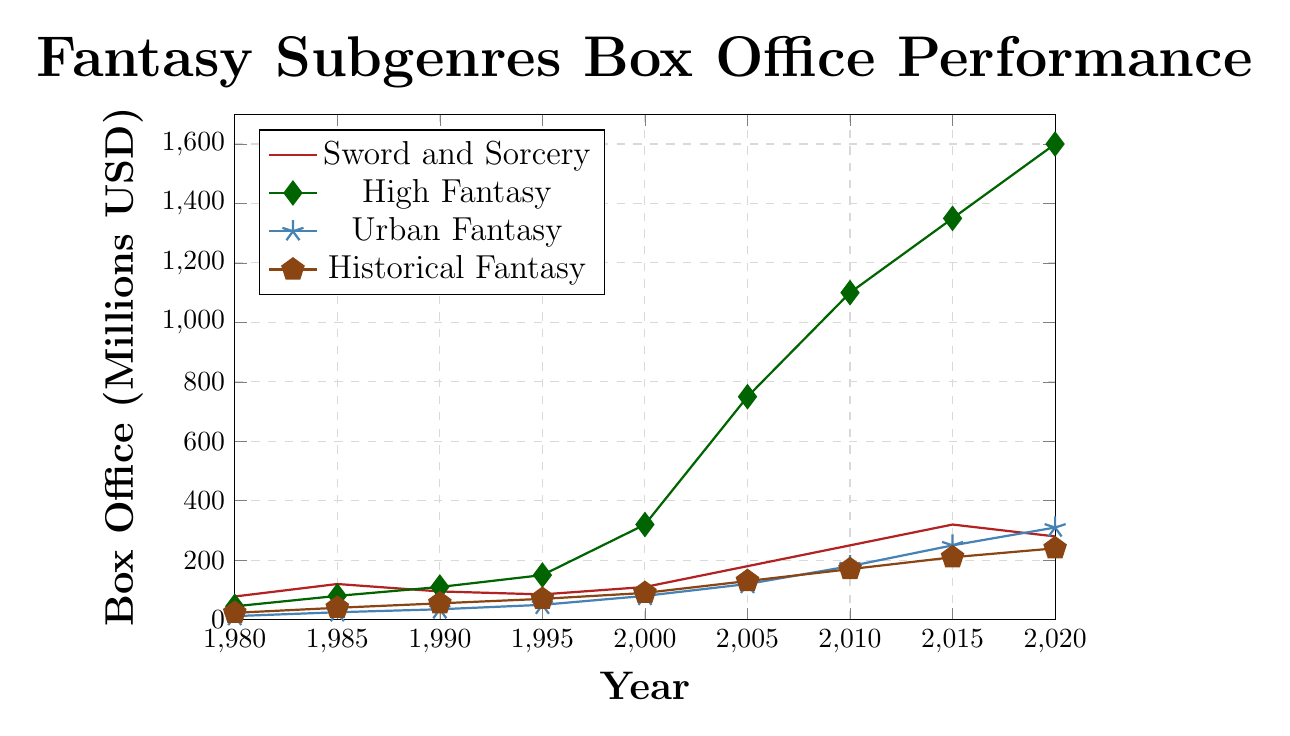what fantasy subgenre had the highest box office performance in 2020? To determine the highest box office performance in 2020, look at the values for each subgenre in that year. High Fantasy stands out with a value of 1600 million USD.
Answer: High Fantasy How did the box office performance of Sword and Sorcery change between 2010 and 2015? Compare the box office values for Sword and Sorcery in 2010 and 2015. It increased from 250 million USD to 320 million USD.
Answer: Increased Which subgenre showed the most consistent growth from 1980 to 2020? By observing the trajectories of all four subgenres, Urban Fantasy shows a steadily rising trend, without any significant declines.
Answer: Urban Fantasy What's the total box office performance of High Fantasy and Urban Fantasy in 2015? Add the box office values for High Fantasy (1350) and Urban Fantasy (250) in 2015. The sum is 1600 million USD.
Answer: 1600 million USD In which year did High Fantasy surpass 1000 million USD for the first time? Analyze the plot points for High Fantasy and find the first year where the value exceeds 1000 million USD. This occurs in 2005.
Answer: 2005 Which subgenre had the least growth from 2000 to 2010? Subtract the 2000 value from the 2010 value for each subgenre. Sword and Sorcery grew from 110 to 250 million USD (140 million USD growth), High Fantasy from 320 to 1100 million USD (780 million USD growth), Urban Fantasy from 80 to 180 million USD (100 million USD growth), and Historical Fantasy from 90 to 170 million USD (80 million USD growth). Thus, Historical Fantasy had the least growth.
Answer: Historical Fantasy What was the box office performance difference between Sword and Sorcery and High Fantasy in 1985? Subtract the 1985 Sword and Sorcery value (120 million USD) from the High Fantasy value (80 million USD), which results in 40 million USD.
Answer: 40 million USD How did the box office performance of Historical Fantasy change between 2005 and 2020? Compare the values for Historical Fantasy in 2005 (130 million USD) and 2020 (240 million USD). It increased by 110 million USD.
Answer: Increased by 110 million USD Which subgenre had the highest relative growth from 2000 to 2005? Calculate the relative growth for each subgenre by dividing the growth amount by the 2000 value. Sword and Sorcery: (180-110)/110 = 0.636, High Fantasy: (750-320)/320 = 1.344, Urban Fantasy: (120-80)/80 = 0.5, Historical Fantasy: (130-90)/90 = 0.444. High Fantasy had the highest relative growth.
Answer: High Fantasy What can you infer about the trend of Urban Fantasy from 1985 to 2020? Observe the Urban Fantasy data points: a steady increase from 25 million USD (1985) to 310 million USD (2020), indicating consistent popularity growth over the years.
Answer: Steady increase 